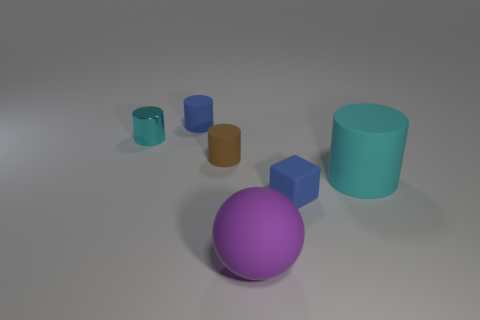Subtract all brown rubber cylinders. How many cylinders are left? 3 Subtract all brown cylinders. How many cylinders are left? 3 Add 1 purple rubber spheres. How many objects exist? 7 Subtract all yellow balls. How many cyan cylinders are left? 2 Subtract all cubes. How many objects are left? 5 Subtract 2 cylinders. How many cylinders are left? 2 Add 2 matte objects. How many matte objects exist? 7 Subtract 0 brown cubes. How many objects are left? 6 Subtract all cyan cylinders. Subtract all green balls. How many cylinders are left? 2 Subtract all blocks. Subtract all cyan balls. How many objects are left? 5 